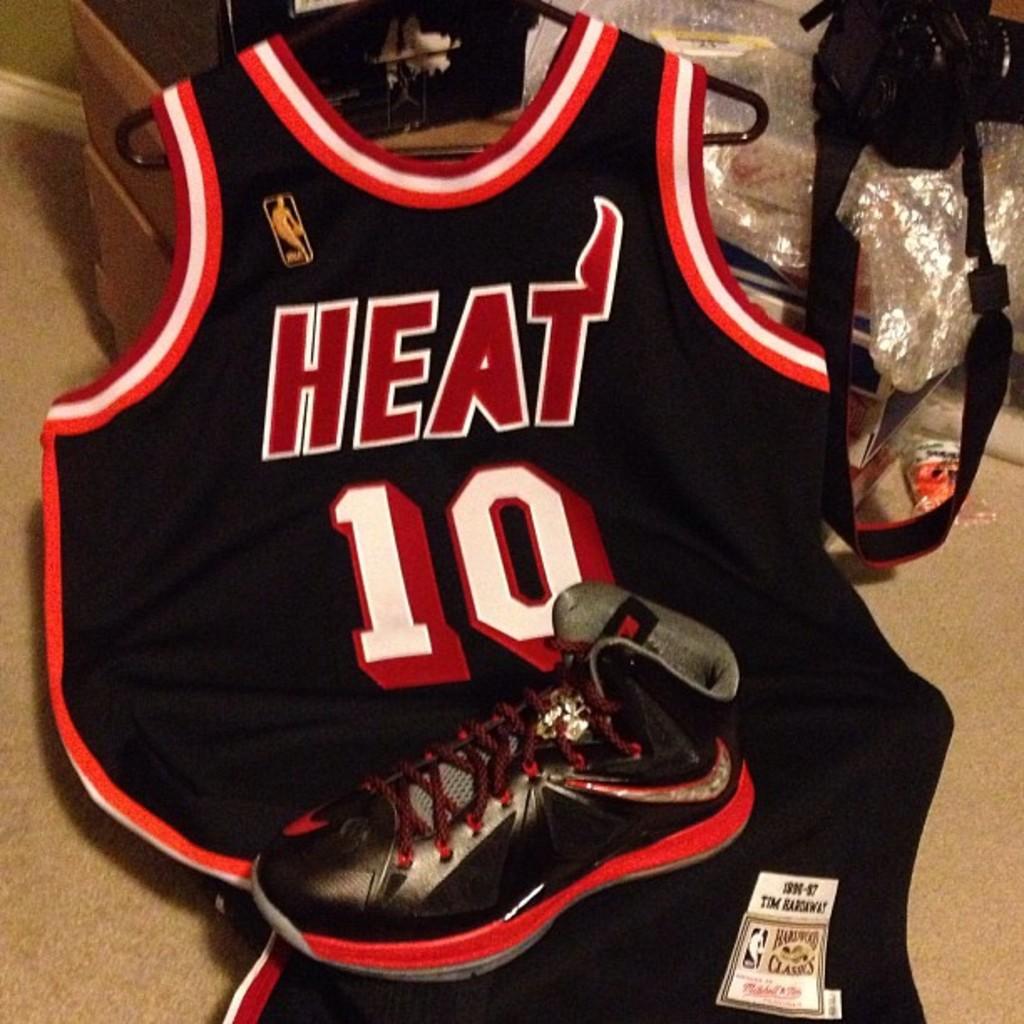What team is the jersey for?
Offer a very short reply. Heat. What number is on the jersey?
Give a very brief answer. 10. 